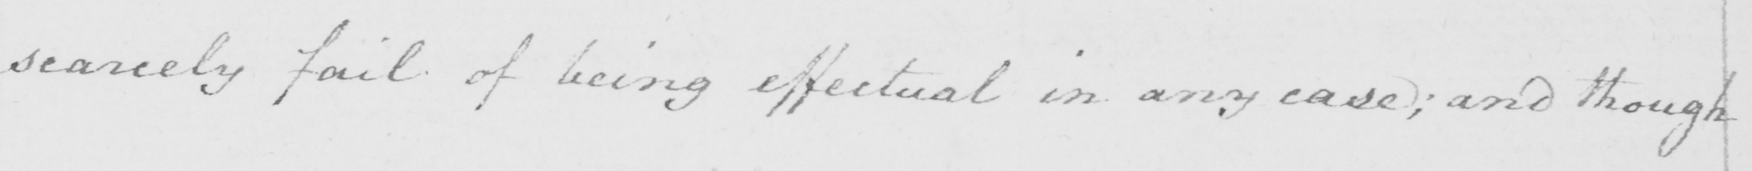What is written in this line of handwriting? scarcely fail of being effectual in any case  ; and though 